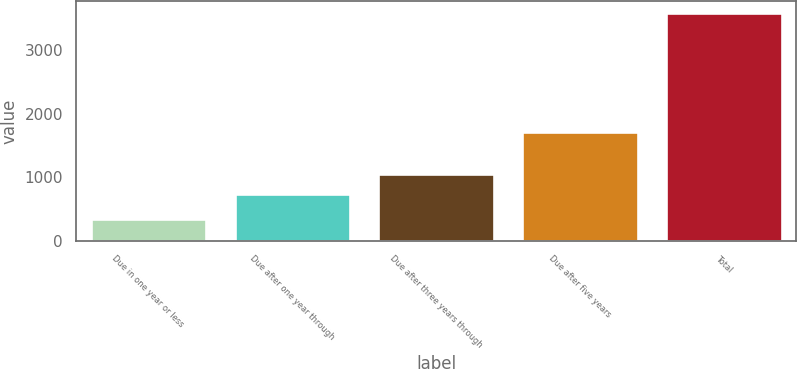Convert chart to OTSL. <chart><loc_0><loc_0><loc_500><loc_500><bar_chart><fcel>Due in one year or less<fcel>Due after one year through<fcel>Due after three years through<fcel>Due after five years<fcel>Total<nl><fcel>347.8<fcel>734.3<fcel>1059.08<fcel>1711.5<fcel>3595.6<nl></chart> 